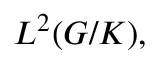Convert formula to latex. <formula><loc_0><loc_0><loc_500><loc_500>L ^ { 2 } ( G / K ) ,</formula> 